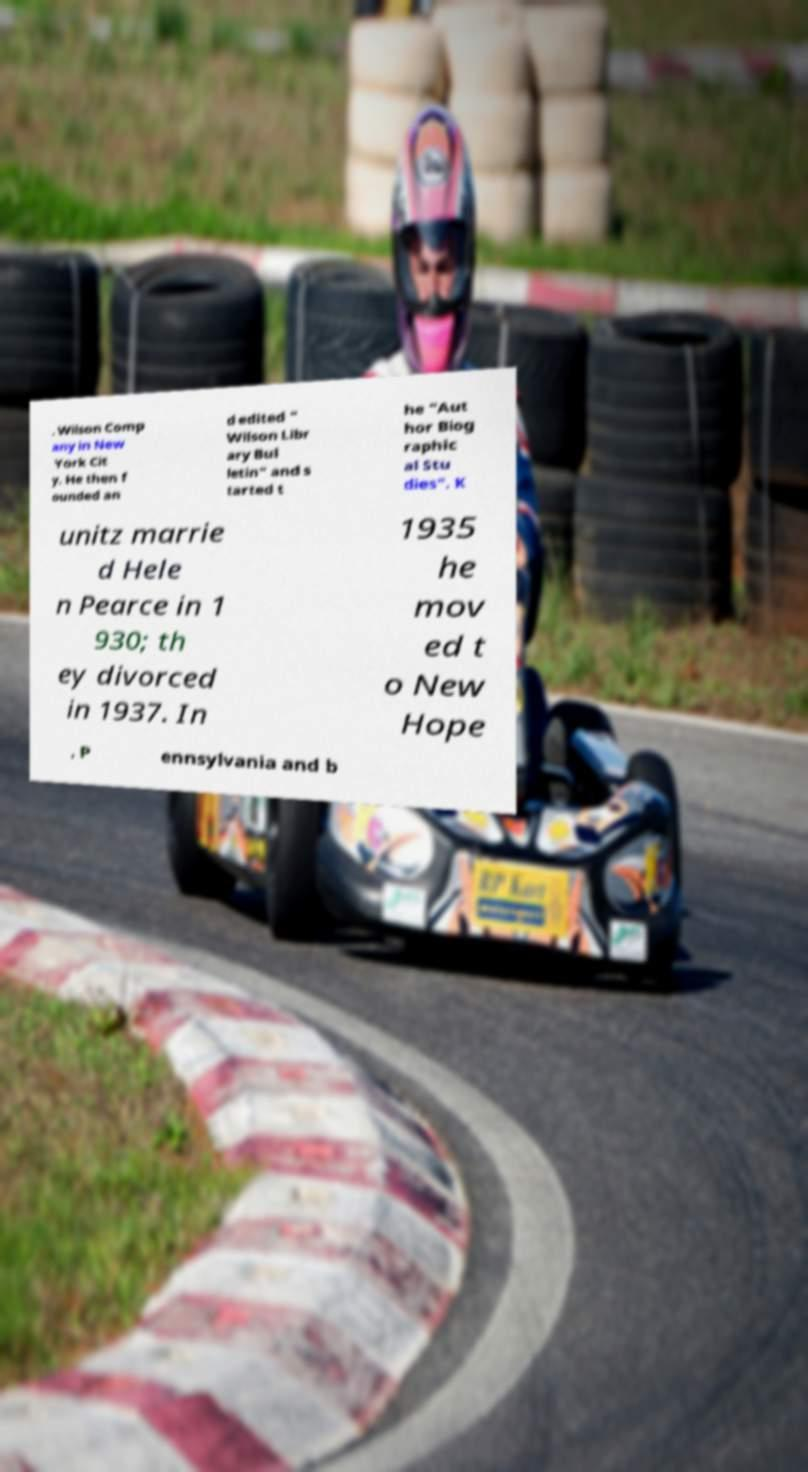I need the written content from this picture converted into text. Can you do that? . Wilson Comp any in New York Cit y. He then f ounded an d edited " Wilson Libr ary Bul letin" and s tarted t he "Aut hor Biog raphic al Stu dies". K unitz marrie d Hele n Pearce in 1 930; th ey divorced in 1937. In 1935 he mov ed t o New Hope , P ennsylvania and b 